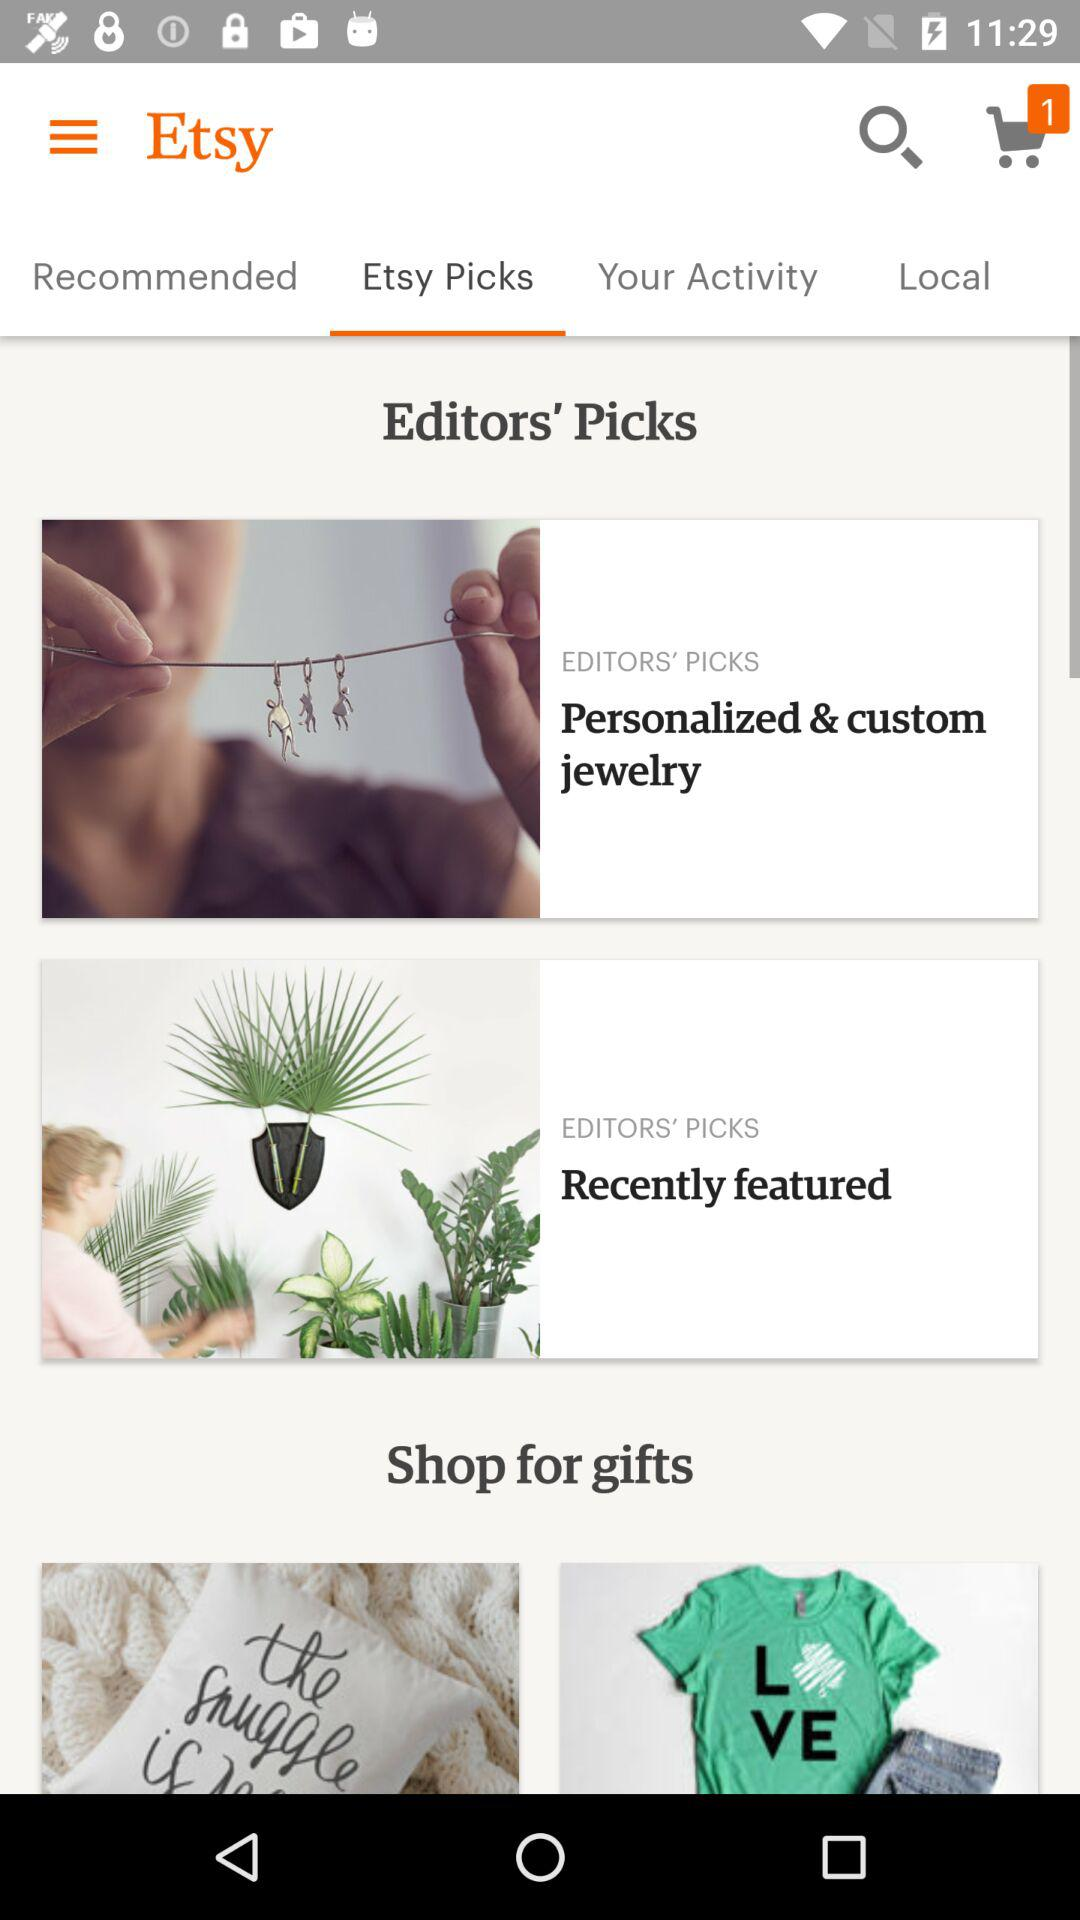How many items are shown in the cart? There is 1 item shown in the cart. 